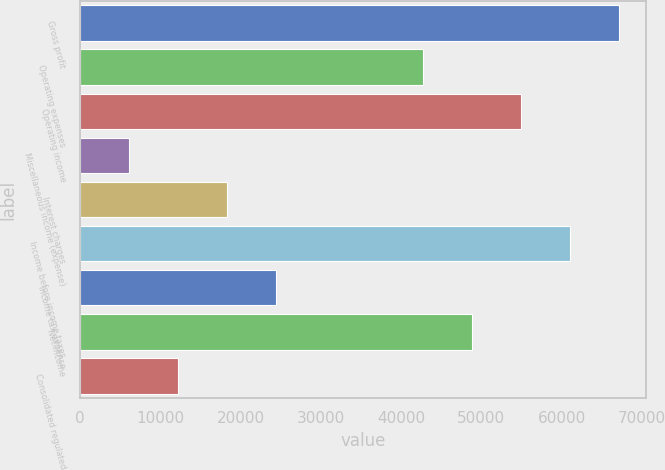Convert chart to OTSL. <chart><loc_0><loc_0><loc_500><loc_500><bar_chart><fcel>Gross profit<fcel>Operating expenses<fcel>Operating income<fcel>Miscellaneous income (expense)<fcel>Interest charges<fcel>Income before income taxes<fcel>Income tax expense<fcel>Net Income<fcel>Consolidated regulated<nl><fcel>67168.2<fcel>42743.7<fcel>54955.9<fcel>6106.87<fcel>18319.1<fcel>61062<fcel>24425.3<fcel>48849.8<fcel>12213<nl></chart> 